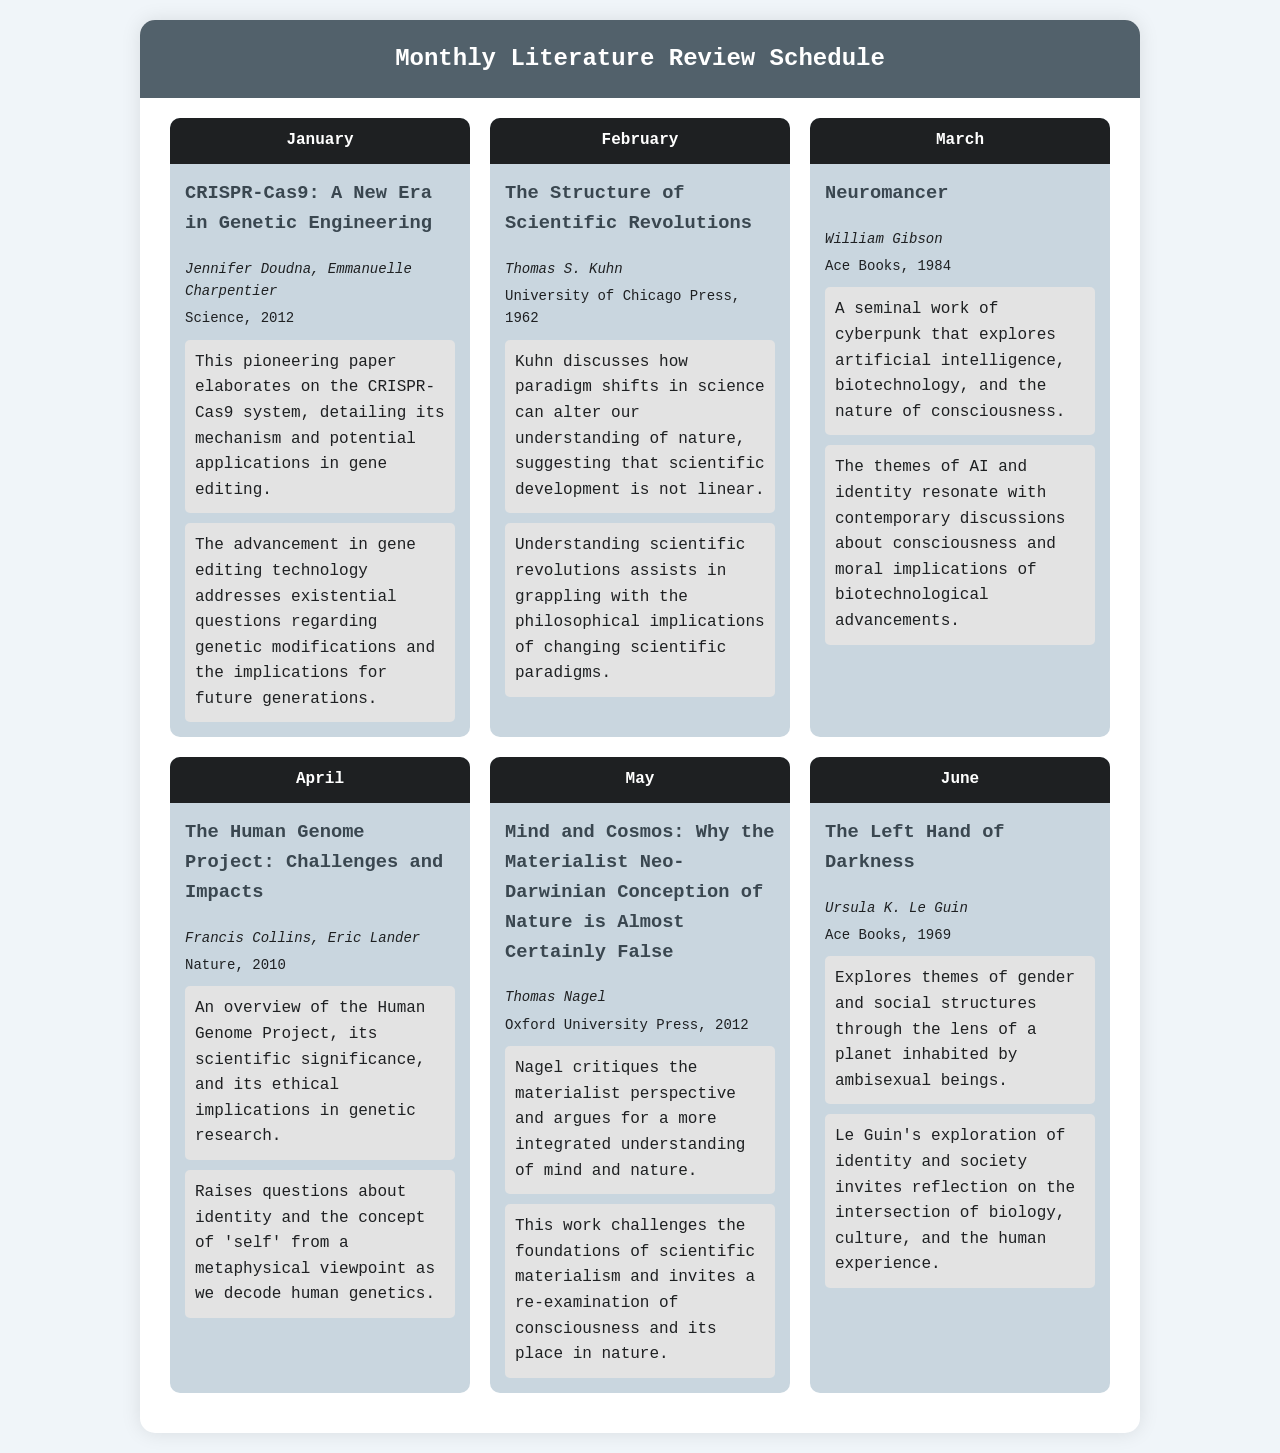What is the title of the paper by Jennifer Doudna and Emmanuelle Charpentier? The title of the paper is provided in the January section of the schedule.
Answer: CRISPR-Cas9: A New Era in Genetic Engineering Who authored "The Structure of Scientific Revolutions"? The authorship of the paper is mentioned in the February section.
Answer: Thomas S. Kuhn In which year was "Neuromancer" published? The publication year of this book is specified in the March section.
Answer: 1984 What is the main theme explored in "The Left Hand of Darkness"? The theme is outlined in the June section, summarizing the content of the book.
Answer: Gender and social structures What scientific project is discussed in the April paper? The project mentioned is found in the summary of the April section.
Answer: Human Genome Project Which paper challenges the materialist perspective of nature? This critique is specified in the May section of the document.
Answer: Mind and Cosmos: Why the Materialist Neo-Darwinian Conception of Nature is Almost Certainly False How many key papers are listed in the schedule? The total number of papers can be counted from the document's sections.
Answer: 6 What is the relevance of the paper by Francis Collins and Eric Lander? The relevance statement for this paper is indicated in the April section.
Answer: Raises questions about identity and the concept of 'self' Which author is associated with the concept of consciousness within nature? This concept is related to an author mentioned in the May section.
Answer: Thomas Nagel 